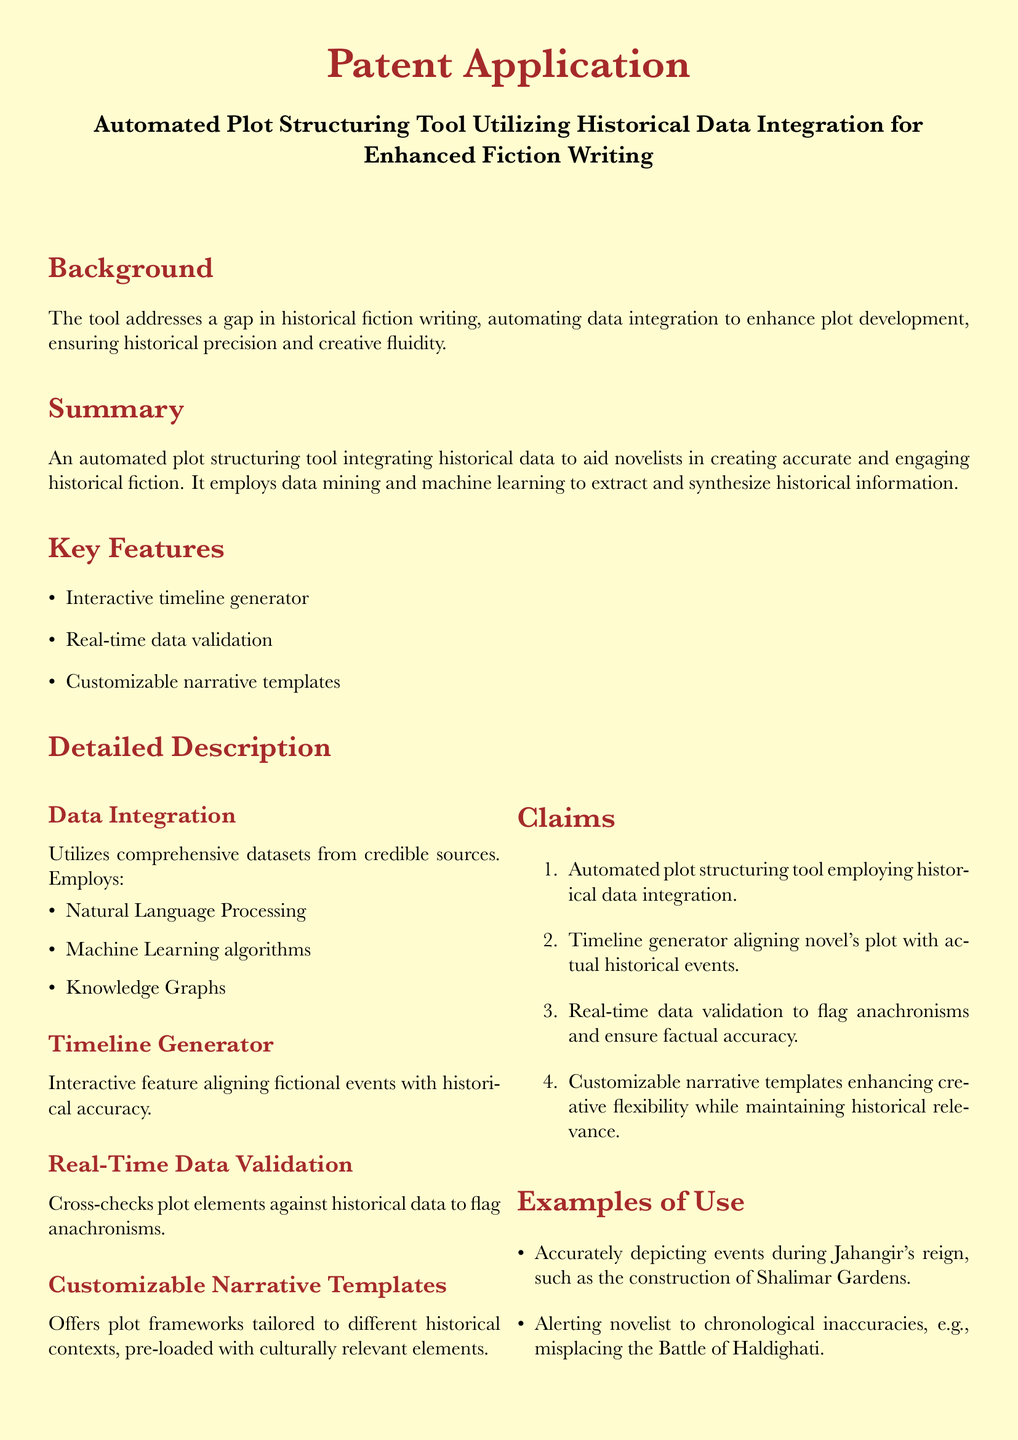What is the title of the patent application? The title is explicitly stated at the top of the document.
Answer: Automated Plot Structuring Tool Utilizing Historical Data Integration for Enhanced Fiction Writing What does the tool aim to address in historical fiction writing? The document mentions a specific gap the tool seeks to fill within the context of historical fiction writing.
Answer: A gap in historical fiction writing What machine learning techniques are mentioned for data integration? The document lists specific techniques used for data integration under the Data Integration section.
Answer: Natural Language Processing, Machine Learning algorithms, Knowledge Graphs How many key features does the tool have? The number of key features is explicitly listed in the Key Features section.
Answer: Three What example is provided for accurate historical depiction? The Examples of Use section provides specific historical events or contexts.
Answer: Jahangir's reign What does the real-time data validation feature do? The document explains the purpose of real-time data validation in the Detailed Description section.
Answer: Flags anachronisms What type of templates does the tool offer? The document describes the nature of the templates under Customizable Narrative Templates.
Answer: Narrative templates tailored to different historical contexts What is the main purpose of the timeline generator? The document highlights the main function of the timeline generator in the Detailed Description section.
Answer: Aligning fictional events with historical accuracy What is the total number of claims made in the application? The number of claims is listed in the Claims section of the document.
Answer: Four 